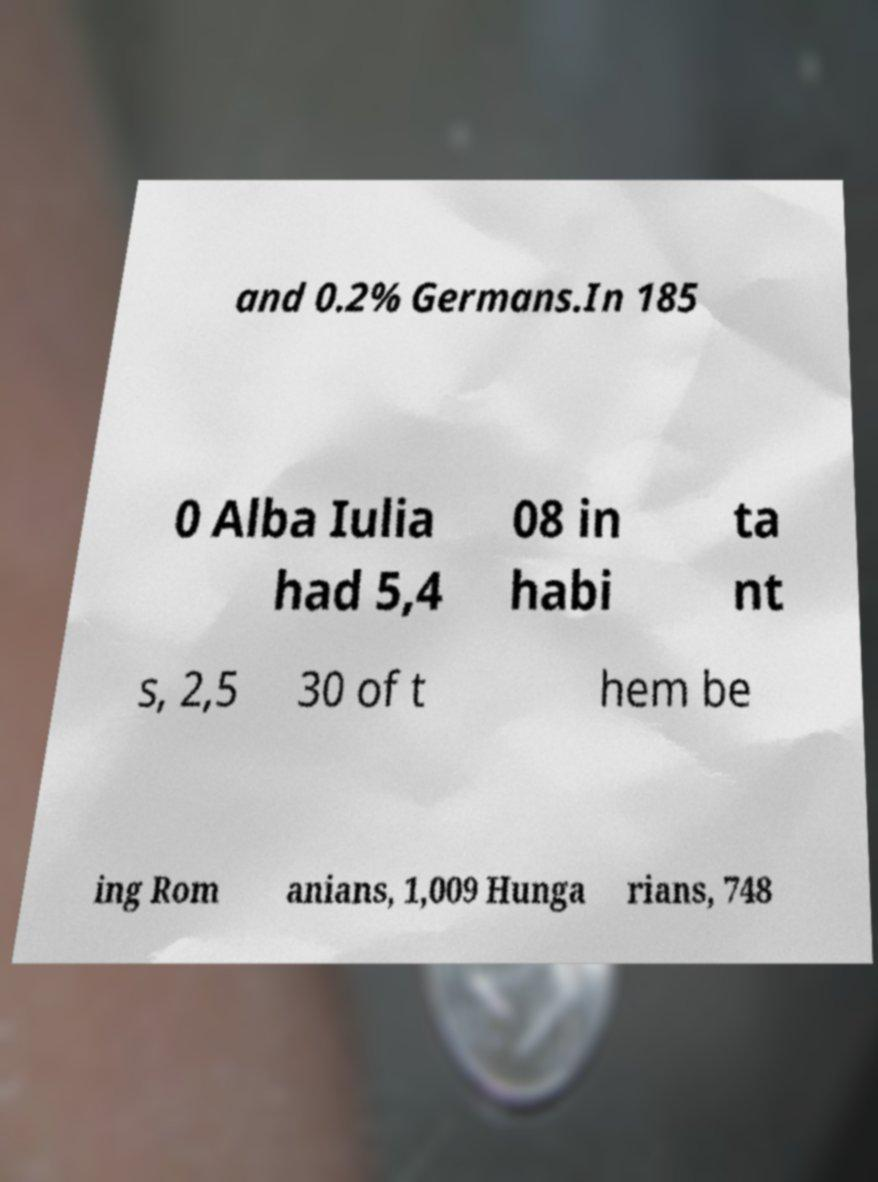Please read and relay the text visible in this image. What does it say? and 0.2% Germans.In 185 0 Alba Iulia had 5,4 08 in habi ta nt s, 2,5 30 of t hem be ing Rom anians, 1,009 Hunga rians, 748 